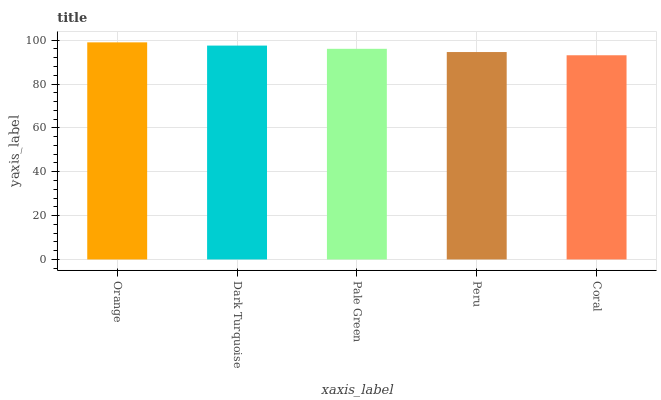Is Coral the minimum?
Answer yes or no. Yes. Is Orange the maximum?
Answer yes or no. Yes. Is Dark Turquoise the minimum?
Answer yes or no. No. Is Dark Turquoise the maximum?
Answer yes or no. No. Is Orange greater than Dark Turquoise?
Answer yes or no. Yes. Is Dark Turquoise less than Orange?
Answer yes or no. Yes. Is Dark Turquoise greater than Orange?
Answer yes or no. No. Is Orange less than Dark Turquoise?
Answer yes or no. No. Is Pale Green the high median?
Answer yes or no. Yes. Is Pale Green the low median?
Answer yes or no. Yes. Is Orange the high median?
Answer yes or no. No. Is Coral the low median?
Answer yes or no. No. 